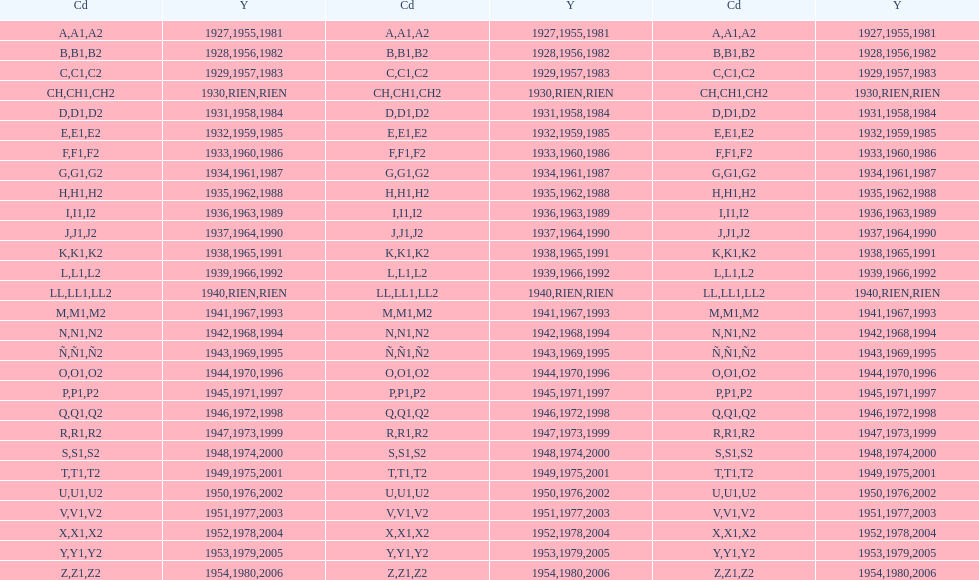Is the e code less than 1950? Yes. 